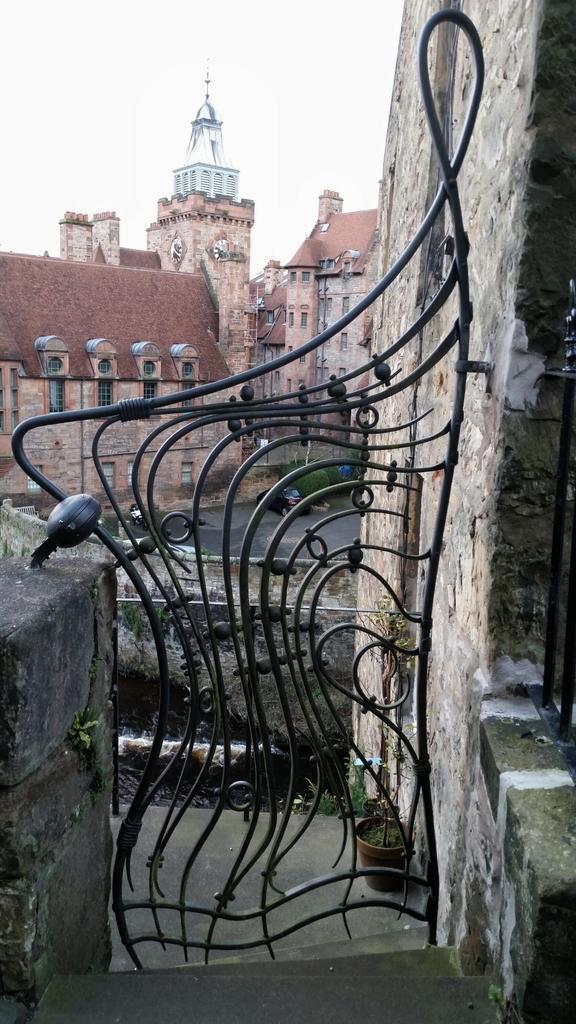Could you give a brief overview of what you see in this image? In this image I can see the metal gate and the wall. In the background I can see the flower pot. I can also see the vehicle in-front of the building and the plants to the side. There is a sky in the back. 